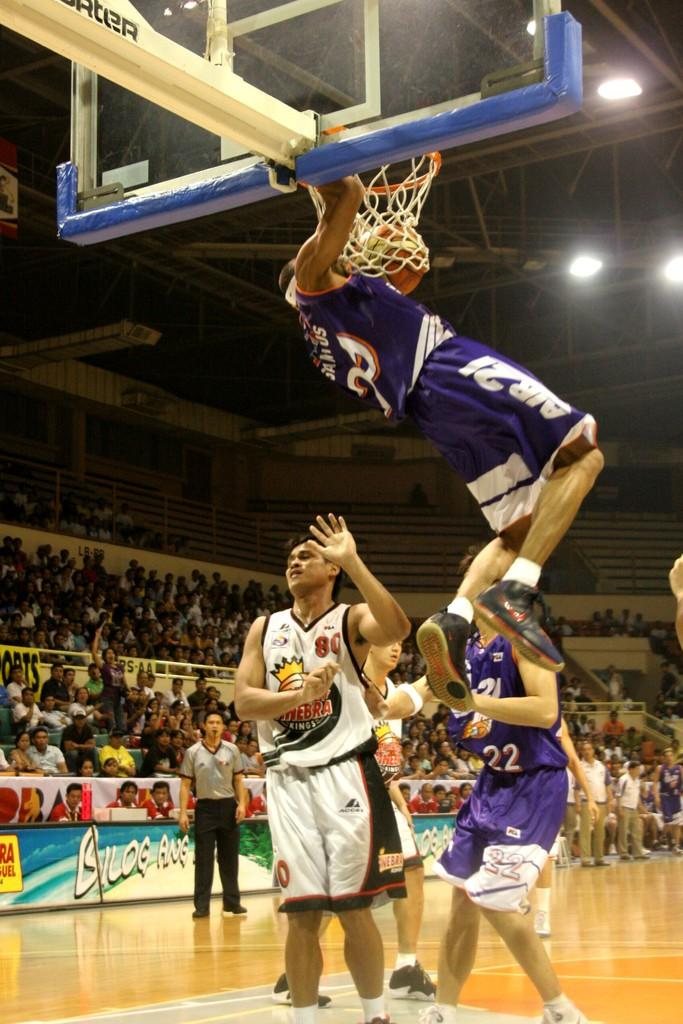<image>
Create a compact narrative representing the image presented. Basketball player dunking while number 80 has his hands up. 